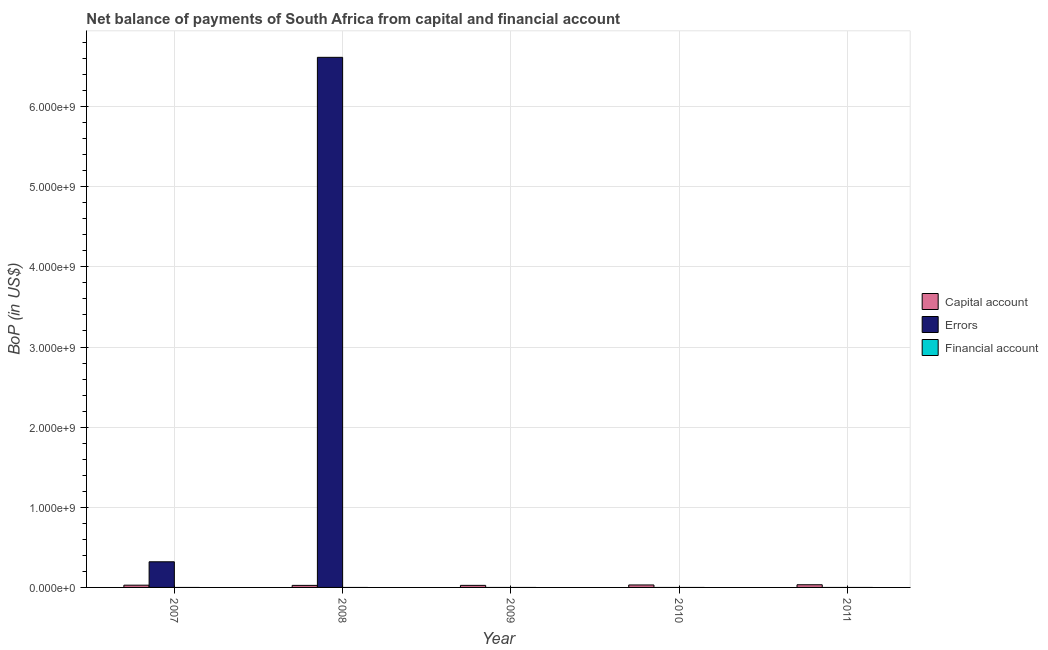How many bars are there on the 1st tick from the left?
Offer a very short reply. 2. How many bars are there on the 2nd tick from the right?
Offer a very short reply. 1. What is the label of the 2nd group of bars from the left?
Give a very brief answer. 2008. In how many cases, is the number of bars for a given year not equal to the number of legend labels?
Your answer should be very brief. 5. Across all years, what is the maximum amount of net capital account?
Offer a terse response. 3.33e+07. Across all years, what is the minimum amount of errors?
Offer a very short reply. 0. What is the total amount of net capital account in the graph?
Make the answer very short. 1.43e+08. What is the difference between the amount of net capital account in 2008 and that in 2009?
Keep it short and to the point. -2.34e+05. What is the difference between the amount of financial account in 2007 and the amount of net capital account in 2008?
Ensure brevity in your answer.  0. In the year 2008, what is the difference between the amount of errors and amount of financial account?
Provide a short and direct response. 0. In how many years, is the amount of financial account greater than 6000000000 US$?
Keep it short and to the point. 0. What is the ratio of the amount of net capital account in 2007 to that in 2009?
Your response must be concise. 1.09. Is the difference between the amount of errors in 2007 and 2008 greater than the difference between the amount of net capital account in 2007 and 2008?
Your answer should be compact. No. What is the difference between the highest and the second highest amount of net capital account?
Provide a short and direct response. 2.56e+06. What is the difference between the highest and the lowest amount of errors?
Provide a succinct answer. 6.62e+09. Is it the case that in every year, the sum of the amount of net capital account and amount of errors is greater than the amount of financial account?
Make the answer very short. Yes. How many bars are there?
Provide a short and direct response. 7. Are all the bars in the graph horizontal?
Give a very brief answer. No. What is the difference between two consecutive major ticks on the Y-axis?
Make the answer very short. 1.00e+09. Are the values on the major ticks of Y-axis written in scientific E-notation?
Your response must be concise. Yes. Does the graph contain any zero values?
Give a very brief answer. Yes. Does the graph contain grids?
Ensure brevity in your answer.  Yes. Where does the legend appear in the graph?
Your answer should be compact. Center right. How many legend labels are there?
Give a very brief answer. 3. What is the title of the graph?
Ensure brevity in your answer.  Net balance of payments of South Africa from capital and financial account. What is the label or title of the Y-axis?
Provide a succinct answer. BoP (in US$). What is the BoP (in US$) of Capital account in 2007?
Provide a succinct answer. 2.80e+07. What is the BoP (in US$) of Errors in 2007?
Make the answer very short. 3.20e+08. What is the BoP (in US$) in Financial account in 2007?
Offer a terse response. 0. What is the BoP (in US$) of Capital account in 2008?
Provide a succinct answer. 2.55e+07. What is the BoP (in US$) in Errors in 2008?
Provide a short and direct response. 6.62e+09. What is the BoP (in US$) of Capital account in 2009?
Offer a very short reply. 2.57e+07. What is the BoP (in US$) in Capital account in 2010?
Offer a very short reply. 3.08e+07. What is the BoP (in US$) of Capital account in 2011?
Give a very brief answer. 3.33e+07. What is the BoP (in US$) of Errors in 2011?
Your answer should be very brief. 0. What is the BoP (in US$) in Financial account in 2011?
Provide a succinct answer. 0. Across all years, what is the maximum BoP (in US$) of Capital account?
Offer a terse response. 3.33e+07. Across all years, what is the maximum BoP (in US$) of Errors?
Give a very brief answer. 6.62e+09. Across all years, what is the minimum BoP (in US$) of Capital account?
Offer a terse response. 2.55e+07. What is the total BoP (in US$) of Capital account in the graph?
Give a very brief answer. 1.43e+08. What is the total BoP (in US$) of Errors in the graph?
Ensure brevity in your answer.  6.94e+09. What is the difference between the BoP (in US$) of Capital account in 2007 and that in 2008?
Your answer should be very brief. 2.48e+06. What is the difference between the BoP (in US$) in Errors in 2007 and that in 2008?
Offer a terse response. -6.30e+09. What is the difference between the BoP (in US$) of Capital account in 2007 and that in 2009?
Offer a very short reply. 2.25e+06. What is the difference between the BoP (in US$) in Capital account in 2007 and that in 2010?
Make the answer very short. -2.79e+06. What is the difference between the BoP (in US$) in Capital account in 2007 and that in 2011?
Keep it short and to the point. -5.35e+06. What is the difference between the BoP (in US$) in Capital account in 2008 and that in 2009?
Offer a terse response. -2.34e+05. What is the difference between the BoP (in US$) in Capital account in 2008 and that in 2010?
Your answer should be compact. -5.27e+06. What is the difference between the BoP (in US$) in Capital account in 2008 and that in 2011?
Provide a succinct answer. -7.83e+06. What is the difference between the BoP (in US$) in Capital account in 2009 and that in 2010?
Your answer should be compact. -5.04e+06. What is the difference between the BoP (in US$) in Capital account in 2009 and that in 2011?
Your response must be concise. -7.60e+06. What is the difference between the BoP (in US$) of Capital account in 2010 and that in 2011?
Offer a very short reply. -2.56e+06. What is the difference between the BoP (in US$) in Capital account in 2007 and the BoP (in US$) in Errors in 2008?
Keep it short and to the point. -6.59e+09. What is the average BoP (in US$) in Capital account per year?
Your response must be concise. 2.87e+07. What is the average BoP (in US$) of Errors per year?
Keep it short and to the point. 1.39e+09. What is the average BoP (in US$) in Financial account per year?
Offer a very short reply. 0. In the year 2007, what is the difference between the BoP (in US$) in Capital account and BoP (in US$) in Errors?
Give a very brief answer. -2.92e+08. In the year 2008, what is the difference between the BoP (in US$) of Capital account and BoP (in US$) of Errors?
Your response must be concise. -6.59e+09. What is the ratio of the BoP (in US$) in Capital account in 2007 to that in 2008?
Give a very brief answer. 1.1. What is the ratio of the BoP (in US$) in Errors in 2007 to that in 2008?
Provide a succinct answer. 0.05. What is the ratio of the BoP (in US$) of Capital account in 2007 to that in 2009?
Give a very brief answer. 1.09. What is the ratio of the BoP (in US$) of Capital account in 2007 to that in 2010?
Offer a terse response. 0.91. What is the ratio of the BoP (in US$) in Capital account in 2007 to that in 2011?
Provide a short and direct response. 0.84. What is the ratio of the BoP (in US$) of Capital account in 2008 to that in 2009?
Your answer should be compact. 0.99. What is the ratio of the BoP (in US$) in Capital account in 2008 to that in 2010?
Offer a very short reply. 0.83. What is the ratio of the BoP (in US$) in Capital account in 2008 to that in 2011?
Provide a succinct answer. 0.77. What is the ratio of the BoP (in US$) in Capital account in 2009 to that in 2010?
Offer a terse response. 0.84. What is the ratio of the BoP (in US$) of Capital account in 2009 to that in 2011?
Ensure brevity in your answer.  0.77. What is the ratio of the BoP (in US$) of Capital account in 2010 to that in 2011?
Make the answer very short. 0.92. What is the difference between the highest and the second highest BoP (in US$) of Capital account?
Your answer should be very brief. 2.56e+06. What is the difference between the highest and the lowest BoP (in US$) of Capital account?
Provide a short and direct response. 7.83e+06. What is the difference between the highest and the lowest BoP (in US$) of Errors?
Provide a short and direct response. 6.62e+09. 